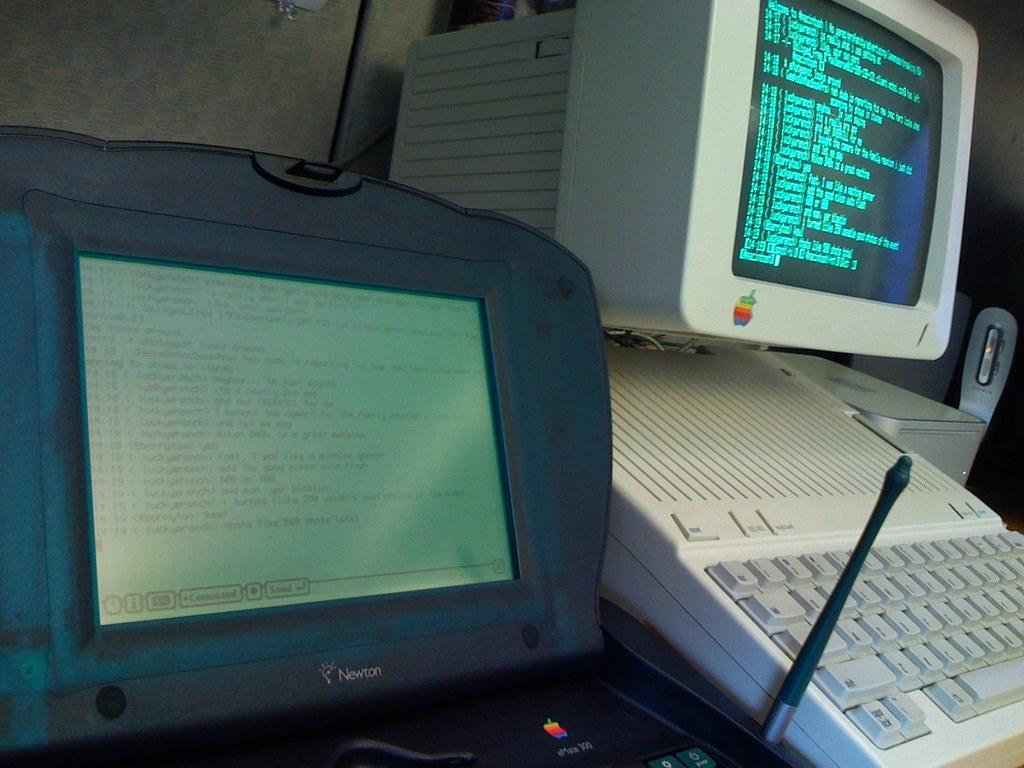What electronic device is the main subject in the image? There is a computer in the image. What is the primary input device for the computer? There is a keyboard in the image. Can you describe any other devices visible in the background of the image? There are other devices visible in the background of the image, but their specific types are not mentioned in the provided facts. What type of news can be heard coming from the harbor in the image? There is no harbor or news source present in the image; it features a computer and a keyboard. 